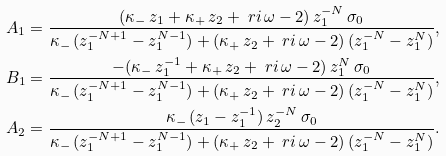Convert formula to latex. <formula><loc_0><loc_0><loc_500><loc_500>A _ { 1 } & = \frac { ( \kappa _ { - } \, z _ { 1 } + \kappa _ { + } \, z _ { 2 } + \ r i \, \omega - 2 ) \, z _ { 1 } ^ { - N } \, \sigma _ { 0 } } { \kappa _ { - } \, ( z _ { 1 } ^ { - N + 1 } - z _ { 1 } ^ { N - 1 } ) + ( \kappa _ { + } \, z _ { 2 } + \ r i \, \omega - 2 ) \, ( z _ { 1 } ^ { - N } - z _ { 1 } ^ { N } ) } , \\ B _ { 1 } & = \frac { - ( \kappa _ { - } \, z _ { 1 } ^ { - 1 } + \kappa _ { + } \, z _ { 2 } + \ r i \, \omega - 2 ) \, z _ { 1 } ^ { N } \, \sigma _ { 0 } } { \kappa _ { - } \, ( z _ { 1 } ^ { - N + 1 } - z _ { 1 } ^ { N - 1 } ) + ( \kappa _ { + } \, z _ { 2 } + \ r i \, \omega - 2 ) \, ( z _ { 1 } ^ { - N } - z _ { 1 } ^ { N } ) } , \\ A _ { 2 } & = \frac { \kappa _ { - } \, ( z _ { 1 } - z _ { 1 } ^ { - 1 } ) \, z _ { 2 } ^ { - N } \, \sigma _ { 0 } } { \kappa _ { - } \, ( z _ { 1 } ^ { - N + 1 } - z _ { 1 } ^ { N - 1 } ) + ( \kappa _ { + } \, z _ { 2 } + \ r i \, \omega - 2 ) \, ( z _ { 1 } ^ { - N } - z _ { 1 } ^ { N } ) } .</formula> 